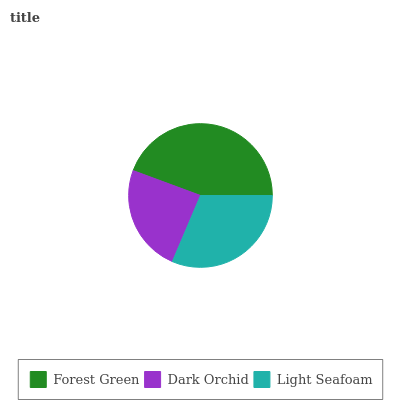Is Dark Orchid the minimum?
Answer yes or no. Yes. Is Forest Green the maximum?
Answer yes or no. Yes. Is Light Seafoam the minimum?
Answer yes or no. No. Is Light Seafoam the maximum?
Answer yes or no. No. Is Light Seafoam greater than Dark Orchid?
Answer yes or no. Yes. Is Dark Orchid less than Light Seafoam?
Answer yes or no. Yes. Is Dark Orchid greater than Light Seafoam?
Answer yes or no. No. Is Light Seafoam less than Dark Orchid?
Answer yes or no. No. Is Light Seafoam the high median?
Answer yes or no. Yes. Is Light Seafoam the low median?
Answer yes or no. Yes. Is Dark Orchid the high median?
Answer yes or no. No. Is Forest Green the low median?
Answer yes or no. No. 